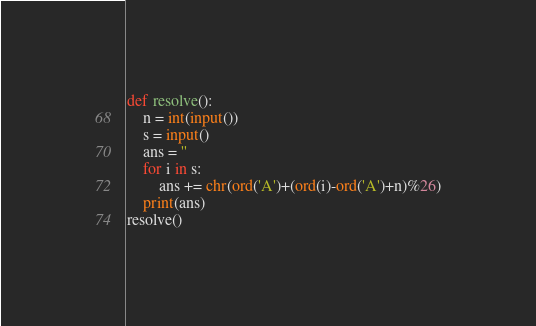Convert code to text. <code><loc_0><loc_0><loc_500><loc_500><_Python_>def resolve():
    n = int(input())
    s = input()
    ans = ''
    for i in s:
        ans += chr(ord('A')+(ord(i)-ord('A')+n)%26)
    print(ans)
resolve()</code> 